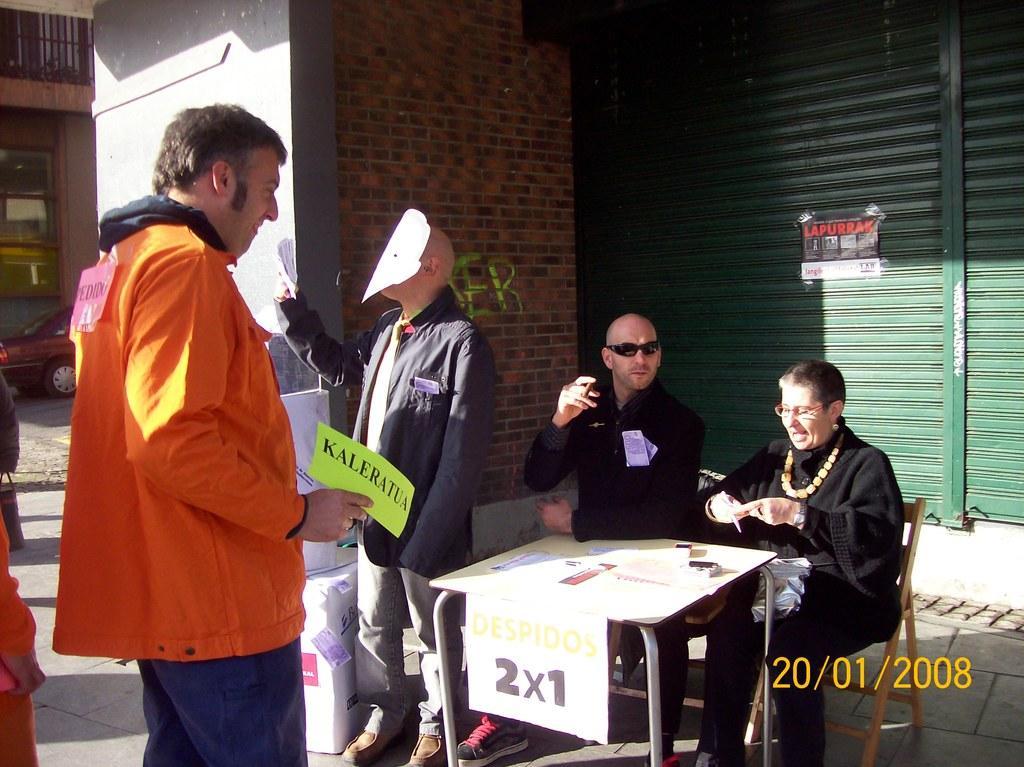Could you give a brief overview of what you see in this image? The two persons wearing black dress is sitting in a chair and there is a table in front of them and there is another person wearing mask is standing beside them and there are some people standing in front of them. 